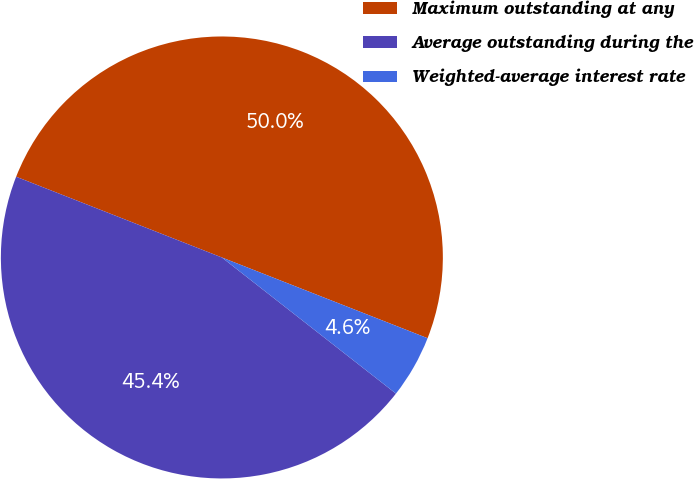Convert chart to OTSL. <chart><loc_0><loc_0><loc_500><loc_500><pie_chart><fcel>Maximum outstanding at any<fcel>Average outstanding during the<fcel>Weighted-average interest rate<nl><fcel>50.0%<fcel>45.39%<fcel>4.61%<nl></chart> 